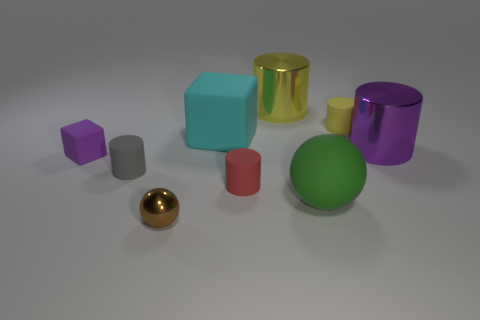How many yellow metallic cylinders are there?
Your answer should be compact. 1. What is the color of the tiny object that is made of the same material as the purple cylinder?
Your answer should be very brief. Brown. How many tiny objects are yellow rubber cylinders or brown metallic spheres?
Make the answer very short. 2. How many purple metallic objects are left of the big yellow metal thing?
Give a very brief answer. 0. What color is the other shiny thing that is the same shape as the big purple object?
Offer a very short reply. Yellow. How many rubber objects are small brown objects or small blue blocks?
Offer a terse response. 0. There is a purple rubber block that is left of the small rubber object on the right side of the tiny red object; is there a purple rubber block to the left of it?
Give a very brief answer. No. What is the color of the matte sphere?
Offer a very short reply. Green. There is a purple thing that is to the left of the tiny gray cylinder; does it have the same shape as the purple metal object?
Provide a short and direct response. No. What number of objects are either tiny brown rubber cylinders or small objects that are behind the brown metallic thing?
Keep it short and to the point. 4. 